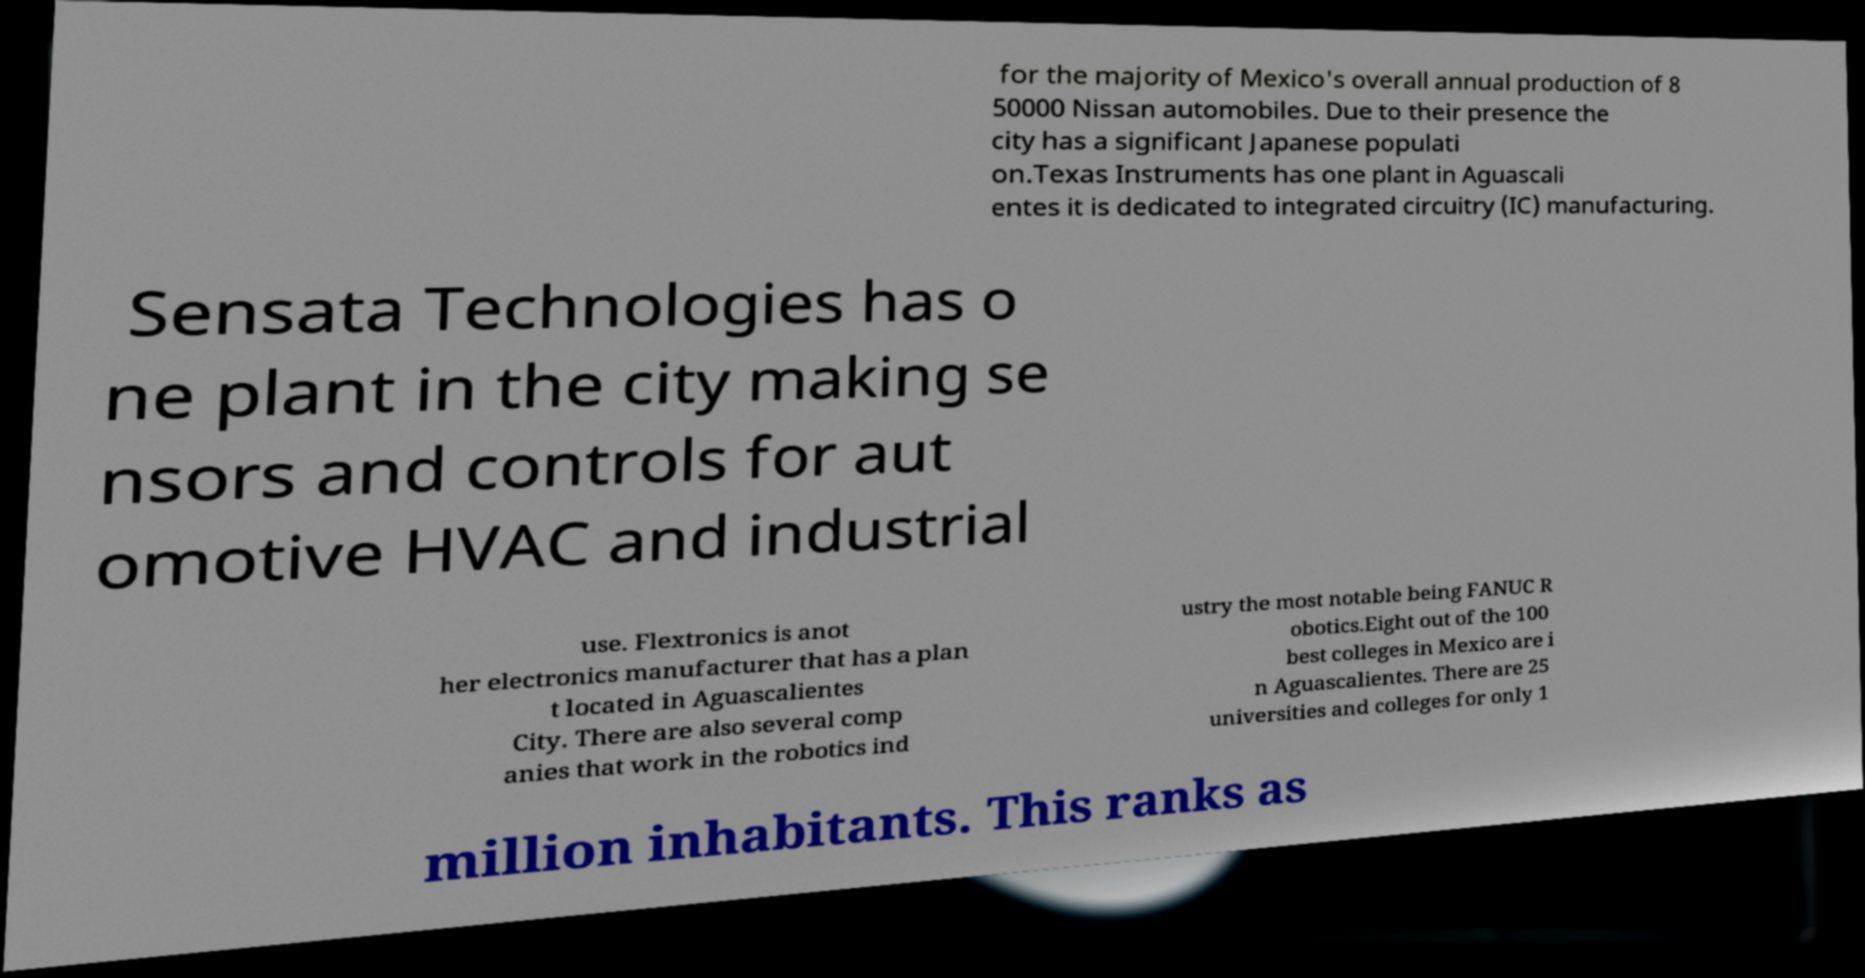Could you extract and type out the text from this image? for the majority of Mexico's overall annual production of 8 50000 Nissan automobiles. Due to their presence the city has a significant Japanese populati on.Texas Instruments has one plant in Aguascali entes it is dedicated to integrated circuitry (IC) manufacturing. Sensata Technologies has o ne plant in the city making se nsors and controls for aut omotive HVAC and industrial use. Flextronics is anot her electronics manufacturer that has a plan t located in Aguascalientes City. There are also several comp anies that work in the robotics ind ustry the most notable being FANUC R obotics.Eight out of the 100 best colleges in Mexico are i n Aguascalientes. There are 25 universities and colleges for only 1 million inhabitants. This ranks as 